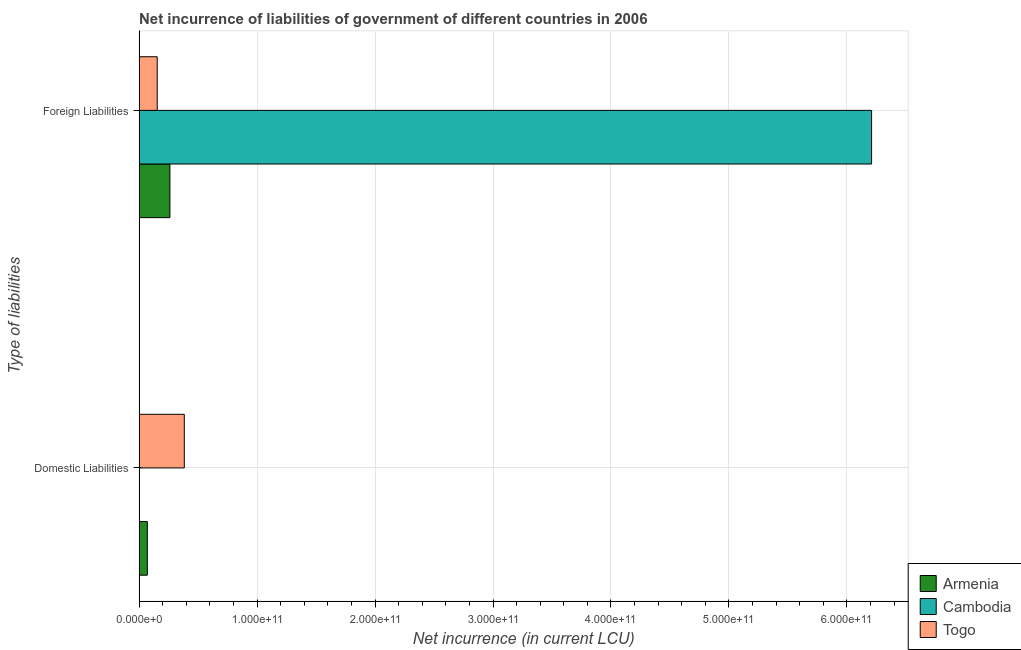How many groups of bars are there?
Give a very brief answer. 2. Are the number of bars on each tick of the Y-axis equal?
Make the answer very short. No. How many bars are there on the 2nd tick from the bottom?
Give a very brief answer. 3. What is the label of the 2nd group of bars from the top?
Your answer should be very brief. Domestic Liabilities. What is the net incurrence of foreign liabilities in Cambodia?
Make the answer very short. 6.21e+11. Across all countries, what is the maximum net incurrence of foreign liabilities?
Offer a very short reply. 6.21e+11. In which country was the net incurrence of foreign liabilities maximum?
Ensure brevity in your answer.  Cambodia. What is the total net incurrence of domestic liabilities in the graph?
Your answer should be compact. 4.53e+1. What is the difference between the net incurrence of domestic liabilities in Togo and that in Armenia?
Provide a short and direct response. 3.13e+1. What is the difference between the net incurrence of foreign liabilities in Armenia and the net incurrence of domestic liabilities in Cambodia?
Provide a short and direct response. 2.61e+1. What is the average net incurrence of domestic liabilities per country?
Ensure brevity in your answer.  1.51e+1. What is the difference between the net incurrence of domestic liabilities and net incurrence of foreign liabilities in Togo?
Ensure brevity in your answer.  2.29e+1. What is the ratio of the net incurrence of foreign liabilities in Cambodia to that in Armenia?
Give a very brief answer. 23.78. Is the net incurrence of foreign liabilities in Cambodia less than that in Togo?
Your answer should be compact. No. How many bars are there?
Provide a succinct answer. 5. Are all the bars in the graph horizontal?
Give a very brief answer. Yes. How many countries are there in the graph?
Your answer should be compact. 3. What is the difference between two consecutive major ticks on the X-axis?
Offer a very short reply. 1.00e+11. Are the values on the major ticks of X-axis written in scientific E-notation?
Offer a very short reply. Yes. Does the graph contain grids?
Your answer should be compact. Yes. How many legend labels are there?
Your answer should be very brief. 3. How are the legend labels stacked?
Keep it short and to the point. Vertical. What is the title of the graph?
Offer a very short reply. Net incurrence of liabilities of government of different countries in 2006. Does "Barbados" appear as one of the legend labels in the graph?
Offer a terse response. No. What is the label or title of the X-axis?
Keep it short and to the point. Net incurrence (in current LCU). What is the label or title of the Y-axis?
Offer a very short reply. Type of liabilities. What is the Net incurrence (in current LCU) of Armenia in Domestic Liabilities?
Ensure brevity in your answer.  6.98e+09. What is the Net incurrence (in current LCU) of Cambodia in Domestic Liabilities?
Provide a succinct answer. 0. What is the Net incurrence (in current LCU) in Togo in Domestic Liabilities?
Your answer should be very brief. 3.83e+1. What is the Net incurrence (in current LCU) of Armenia in Foreign Liabilities?
Your answer should be very brief. 2.61e+1. What is the Net incurrence (in current LCU) in Cambodia in Foreign Liabilities?
Keep it short and to the point. 6.21e+11. What is the Net incurrence (in current LCU) of Togo in Foreign Liabilities?
Your response must be concise. 1.54e+1. Across all Type of liabilities, what is the maximum Net incurrence (in current LCU) in Armenia?
Your answer should be compact. 2.61e+1. Across all Type of liabilities, what is the maximum Net incurrence (in current LCU) of Cambodia?
Your answer should be compact. 6.21e+11. Across all Type of liabilities, what is the maximum Net incurrence (in current LCU) of Togo?
Give a very brief answer. 3.83e+1. Across all Type of liabilities, what is the minimum Net incurrence (in current LCU) of Armenia?
Your answer should be very brief. 6.98e+09. Across all Type of liabilities, what is the minimum Net incurrence (in current LCU) in Togo?
Ensure brevity in your answer.  1.54e+1. What is the total Net incurrence (in current LCU) in Armenia in the graph?
Ensure brevity in your answer.  3.31e+1. What is the total Net incurrence (in current LCU) of Cambodia in the graph?
Offer a very short reply. 6.21e+11. What is the total Net incurrence (in current LCU) in Togo in the graph?
Your response must be concise. 5.37e+1. What is the difference between the Net incurrence (in current LCU) of Armenia in Domestic Liabilities and that in Foreign Liabilities?
Your answer should be very brief. -1.91e+1. What is the difference between the Net incurrence (in current LCU) of Togo in Domestic Liabilities and that in Foreign Liabilities?
Your answer should be very brief. 2.29e+1. What is the difference between the Net incurrence (in current LCU) of Armenia in Domestic Liabilities and the Net incurrence (in current LCU) of Cambodia in Foreign Liabilities?
Provide a succinct answer. -6.14e+11. What is the difference between the Net incurrence (in current LCU) in Armenia in Domestic Liabilities and the Net incurrence (in current LCU) in Togo in Foreign Liabilities?
Your response must be concise. -8.37e+09. What is the average Net incurrence (in current LCU) in Armenia per Type of liabilities?
Make the answer very short. 1.65e+1. What is the average Net incurrence (in current LCU) of Cambodia per Type of liabilities?
Ensure brevity in your answer.  3.10e+11. What is the average Net incurrence (in current LCU) in Togo per Type of liabilities?
Give a very brief answer. 2.68e+1. What is the difference between the Net incurrence (in current LCU) in Armenia and Net incurrence (in current LCU) in Togo in Domestic Liabilities?
Give a very brief answer. -3.13e+1. What is the difference between the Net incurrence (in current LCU) in Armenia and Net incurrence (in current LCU) in Cambodia in Foreign Liabilities?
Keep it short and to the point. -5.95e+11. What is the difference between the Net incurrence (in current LCU) of Armenia and Net incurrence (in current LCU) of Togo in Foreign Liabilities?
Offer a very short reply. 1.07e+1. What is the difference between the Net incurrence (in current LCU) of Cambodia and Net incurrence (in current LCU) of Togo in Foreign Liabilities?
Offer a very short reply. 6.06e+11. What is the ratio of the Net incurrence (in current LCU) in Armenia in Domestic Liabilities to that in Foreign Liabilities?
Offer a very short reply. 0.27. What is the ratio of the Net incurrence (in current LCU) in Togo in Domestic Liabilities to that in Foreign Liabilities?
Provide a succinct answer. 2.49. What is the difference between the highest and the second highest Net incurrence (in current LCU) in Armenia?
Give a very brief answer. 1.91e+1. What is the difference between the highest and the second highest Net incurrence (in current LCU) in Togo?
Give a very brief answer. 2.29e+1. What is the difference between the highest and the lowest Net incurrence (in current LCU) of Armenia?
Keep it short and to the point. 1.91e+1. What is the difference between the highest and the lowest Net incurrence (in current LCU) of Cambodia?
Ensure brevity in your answer.  6.21e+11. What is the difference between the highest and the lowest Net incurrence (in current LCU) of Togo?
Your answer should be compact. 2.29e+1. 